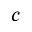Convert formula to latex. <formula><loc_0><loc_0><loc_500><loc_500>c</formula> 